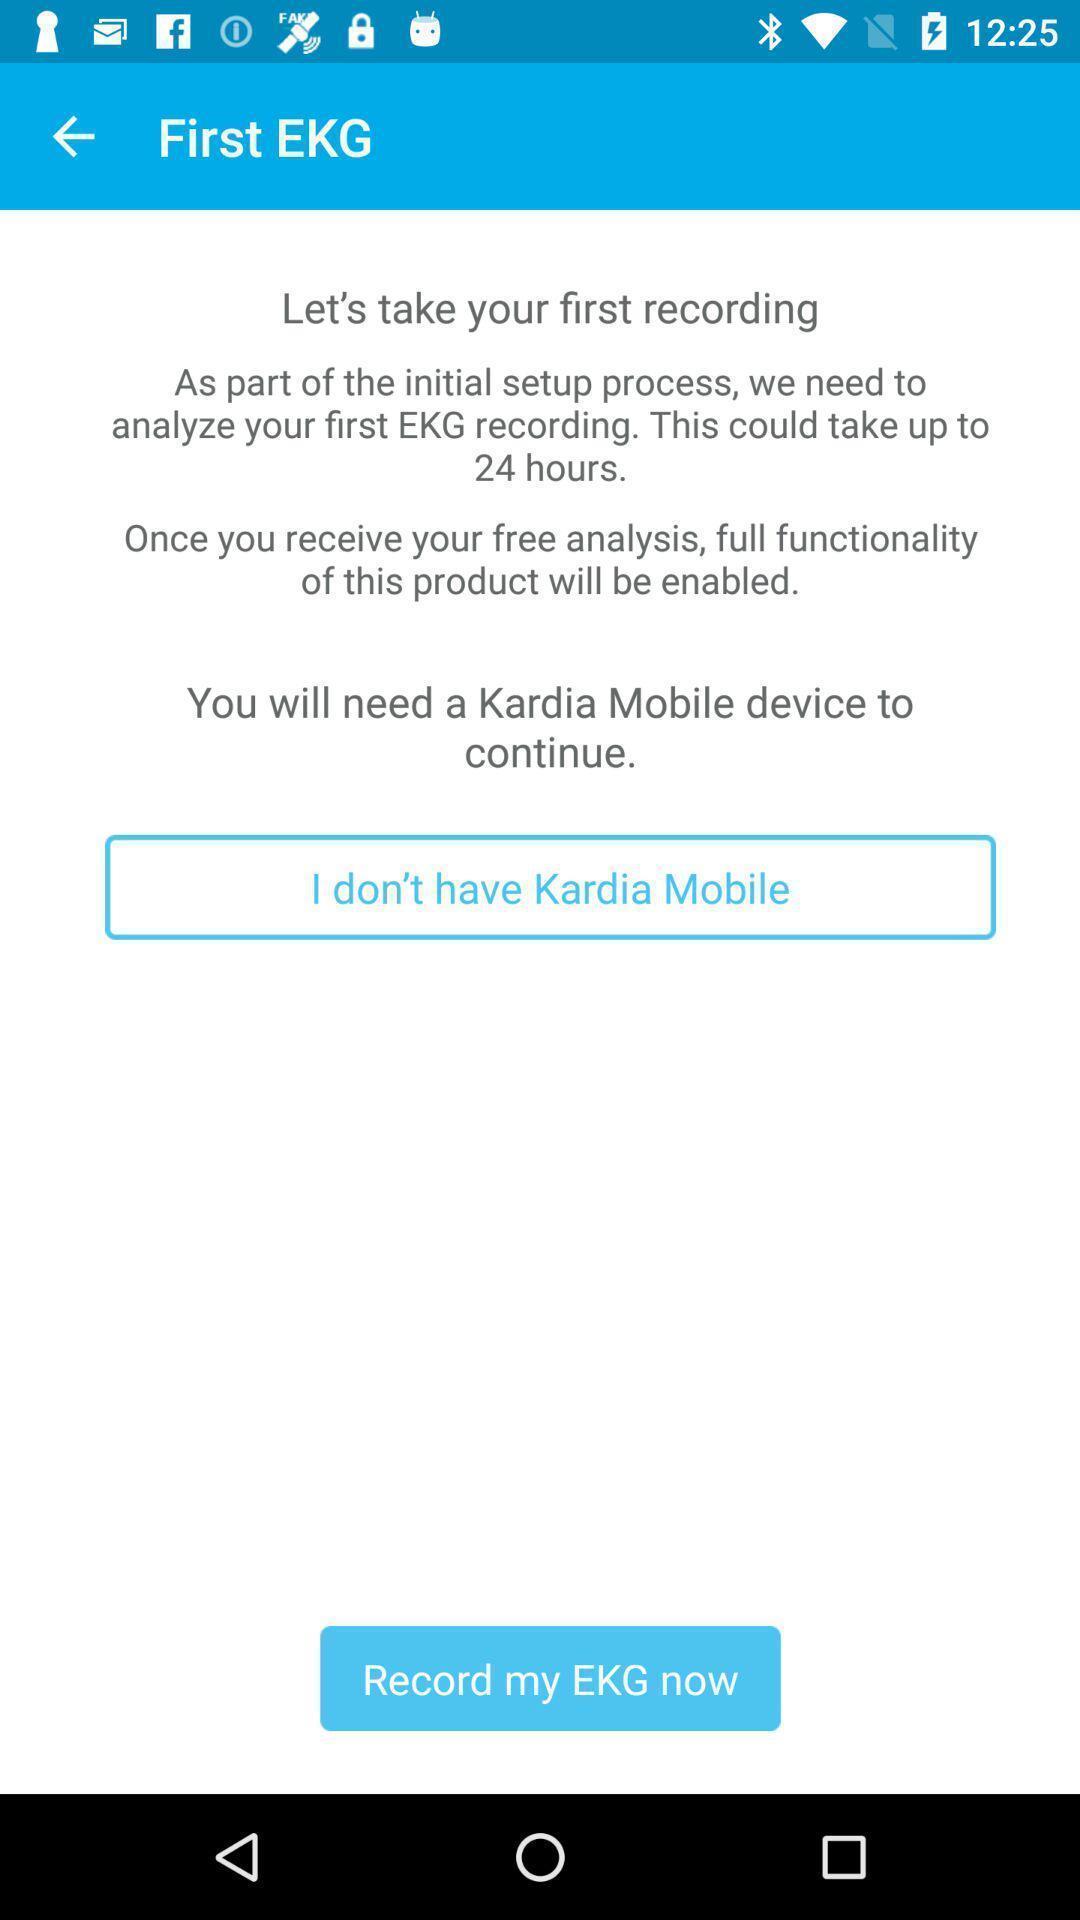Explain what's happening in this screen capture. Screen shows the information about an application. 